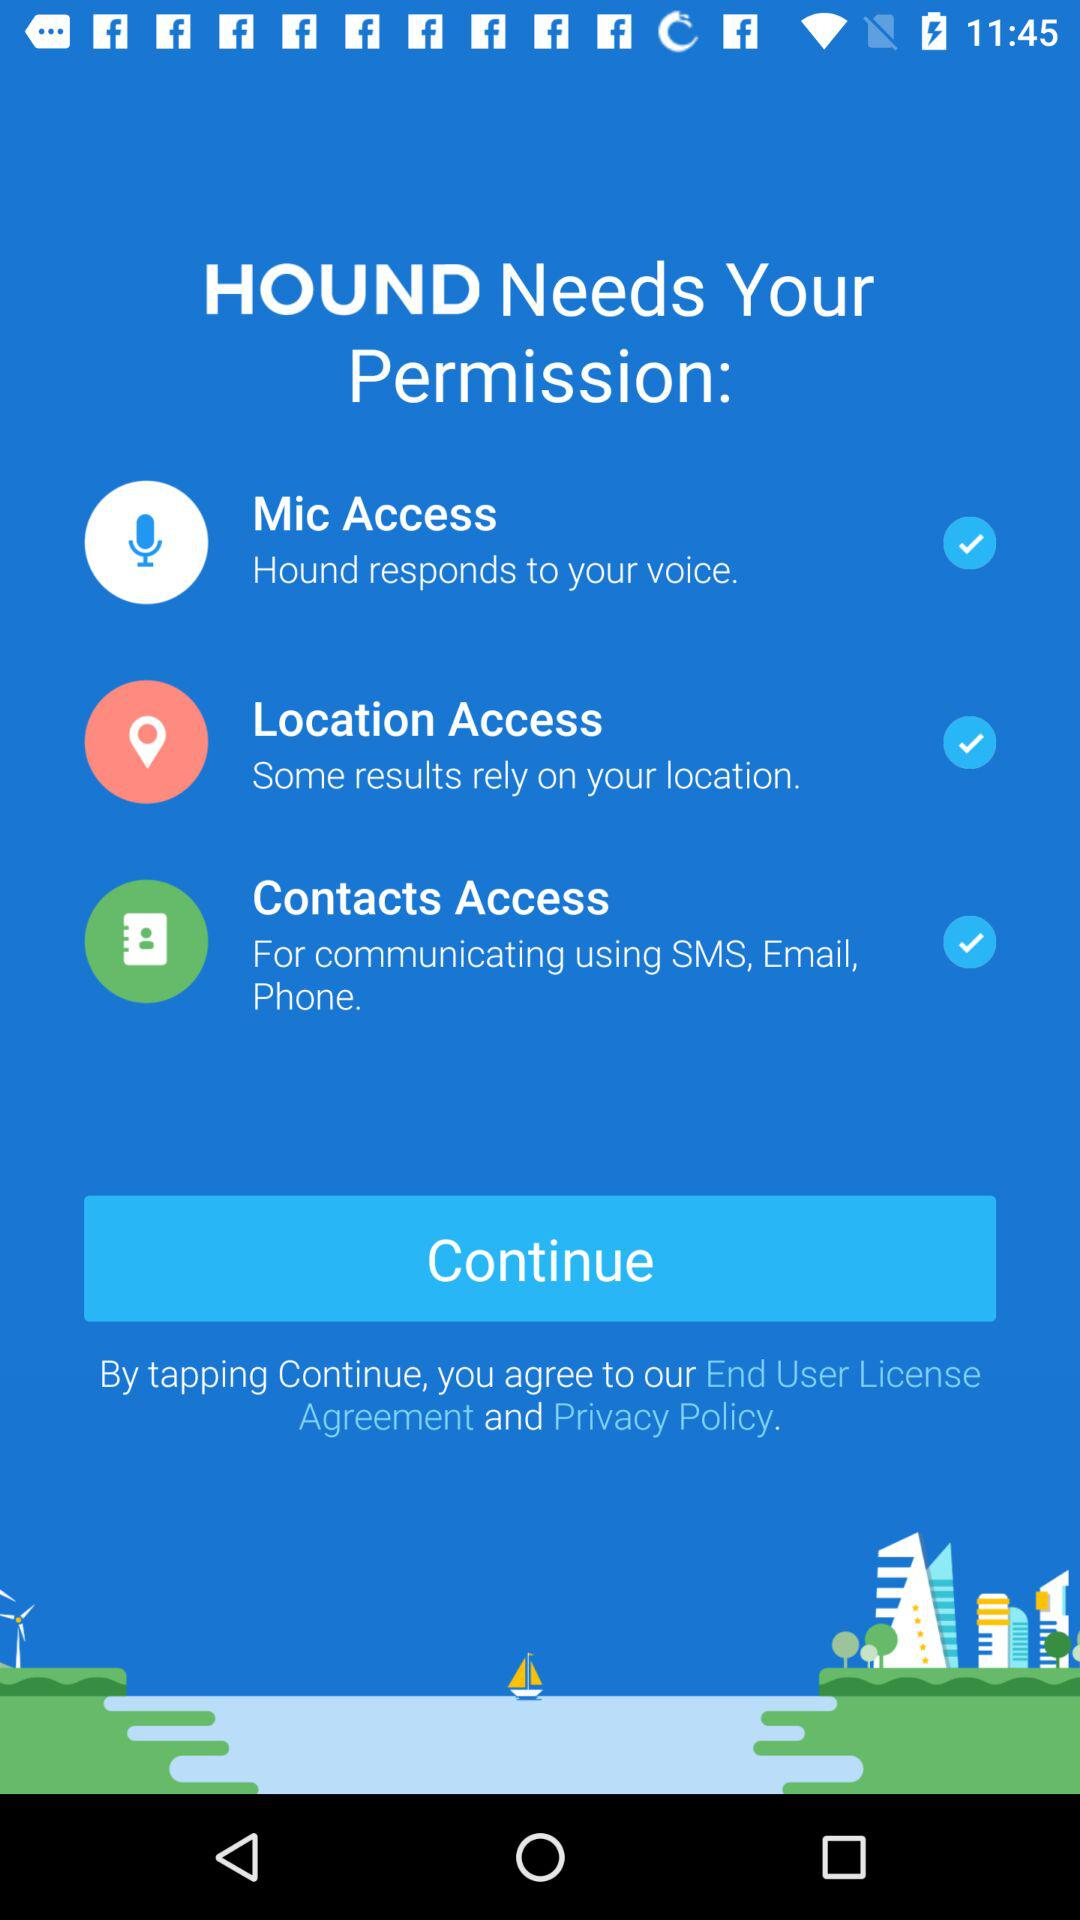What is the application name? The application name is "HOUND". 